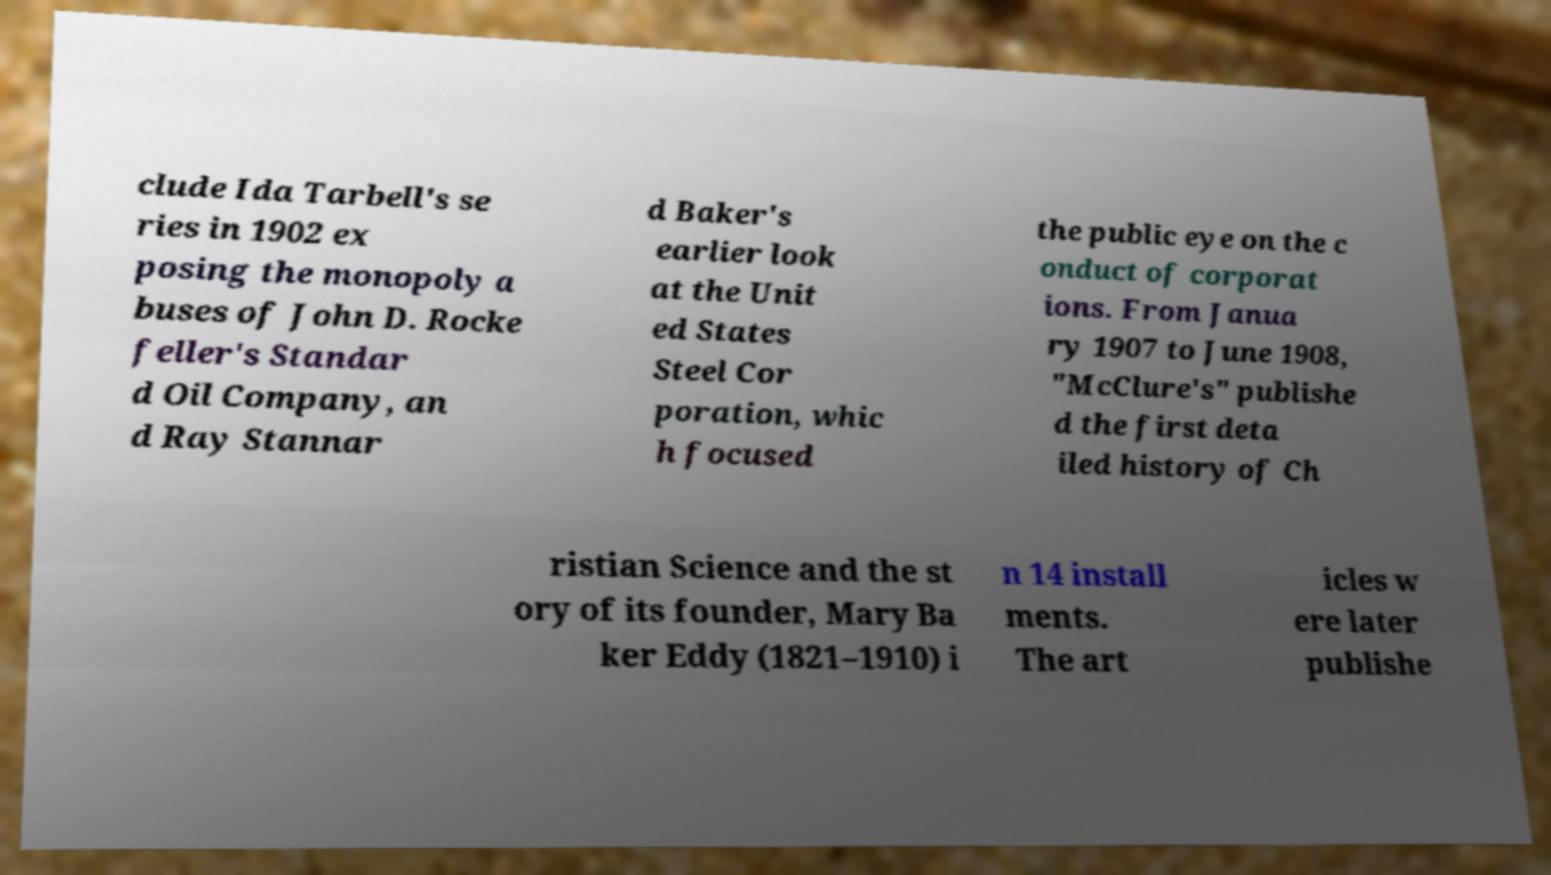For documentation purposes, I need the text within this image transcribed. Could you provide that? clude Ida Tarbell's se ries in 1902 ex posing the monopoly a buses of John D. Rocke feller's Standar d Oil Company, an d Ray Stannar d Baker's earlier look at the Unit ed States Steel Cor poration, whic h focused the public eye on the c onduct of corporat ions. From Janua ry 1907 to June 1908, "McClure's" publishe d the first deta iled history of Ch ristian Science and the st ory of its founder, Mary Ba ker Eddy (1821–1910) i n 14 install ments. The art icles w ere later publishe 